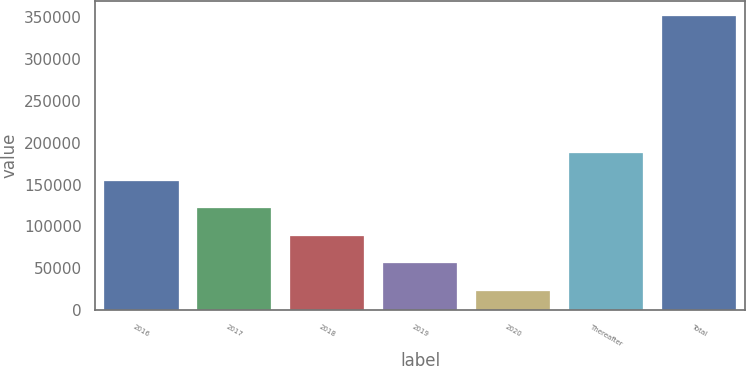Convert chart to OTSL. <chart><loc_0><loc_0><loc_500><loc_500><bar_chart><fcel>2016<fcel>2017<fcel>2018<fcel>2019<fcel>2020<fcel>Thereafter<fcel>Total<nl><fcel>154369<fcel>121592<fcel>88815.4<fcel>56038.7<fcel>23262<fcel>187146<fcel>351029<nl></chart> 